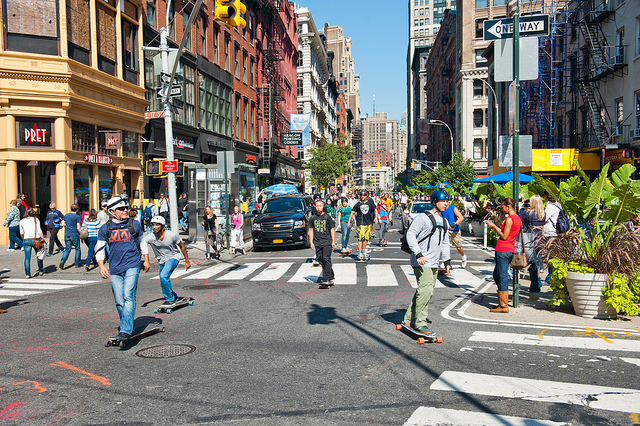Read all the text in this image. PRET WAY ONE 